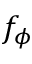Convert formula to latex. <formula><loc_0><loc_0><loc_500><loc_500>f _ { \phi }</formula> 